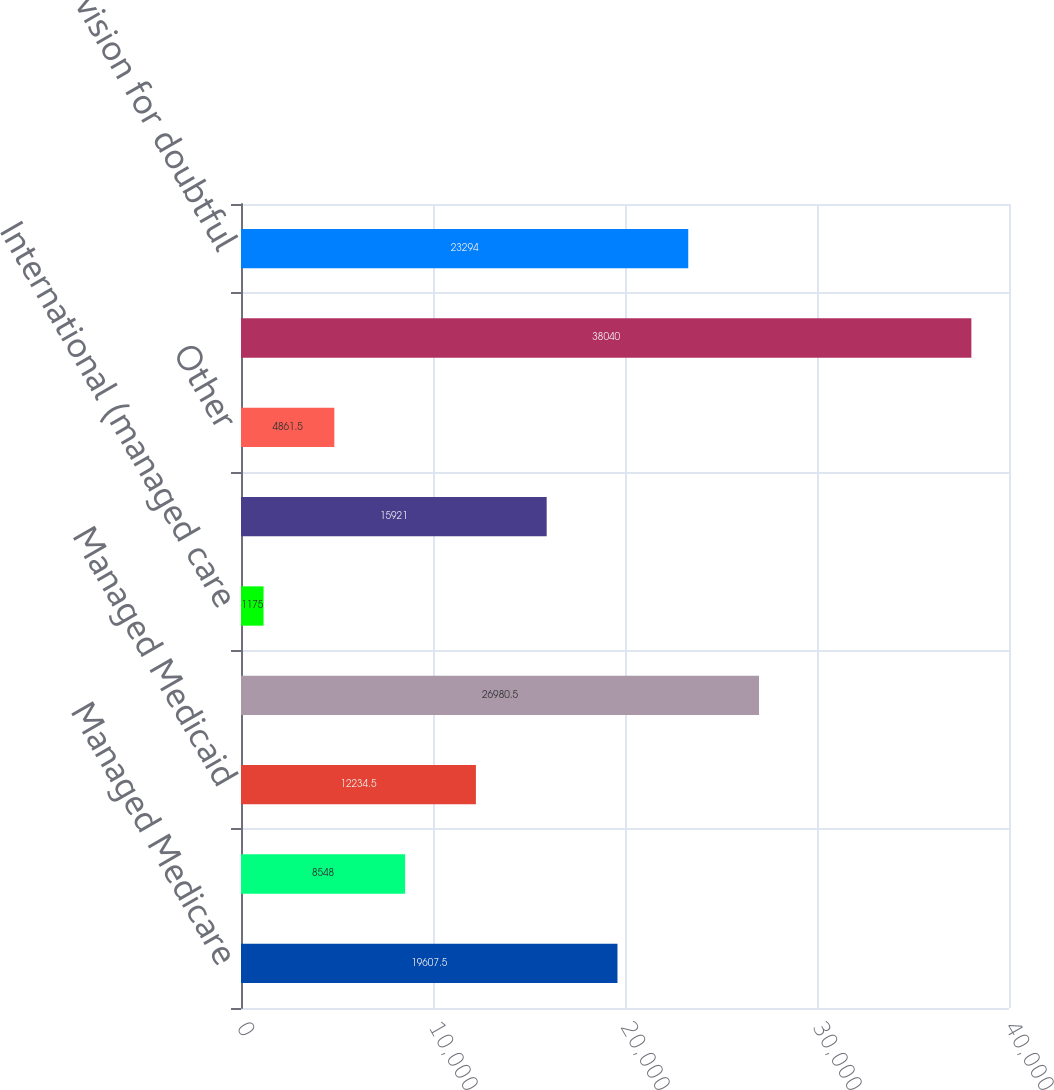<chart> <loc_0><loc_0><loc_500><loc_500><bar_chart><fcel>Managed Medicare<fcel>Medicaid<fcel>Managed Medicaid<fcel>Managed care and other<fcel>International (managed care<fcel>Uninsured<fcel>Other<fcel>Revenues before provision for<fcel>Provision for doubtful<nl><fcel>19607.5<fcel>8548<fcel>12234.5<fcel>26980.5<fcel>1175<fcel>15921<fcel>4861.5<fcel>38040<fcel>23294<nl></chart> 